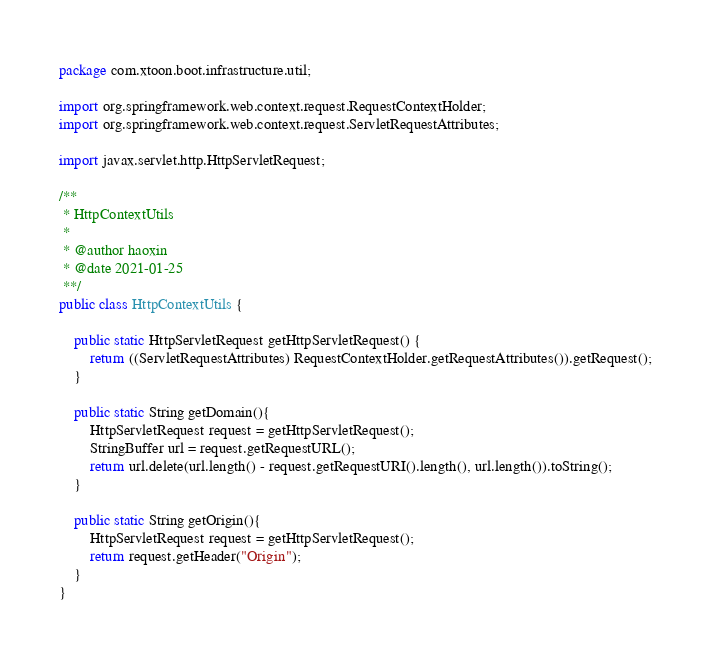<code> <loc_0><loc_0><loc_500><loc_500><_Java_>package com.xtoon.boot.infrastructure.util;

import org.springframework.web.context.request.RequestContextHolder;
import org.springframework.web.context.request.ServletRequestAttributes;

import javax.servlet.http.HttpServletRequest;

/**
 * HttpContextUtils
 *
 * @author haoxin
 * @date 2021-01-25
 **/
public class HttpContextUtils {

    public static HttpServletRequest getHttpServletRequest() {
        return ((ServletRequestAttributes) RequestContextHolder.getRequestAttributes()).getRequest();
    }

    public static String getDomain(){
        HttpServletRequest request = getHttpServletRequest();
        StringBuffer url = request.getRequestURL();
        return url.delete(url.length() - request.getRequestURI().length(), url.length()).toString();
    }

    public static String getOrigin(){
        HttpServletRequest request = getHttpServletRequest();
        return request.getHeader("Origin");
    }
}
</code> 